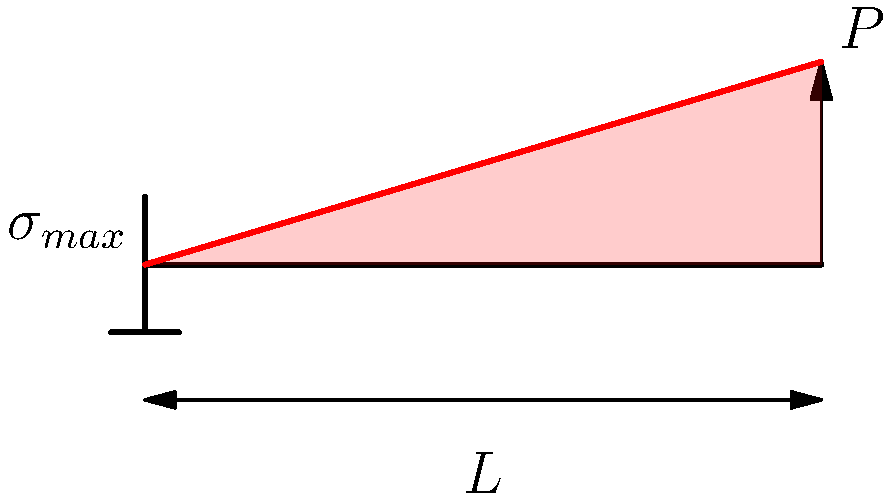In the context of international music competitions, stage design often involves cantilever structures for lighting and sound equipment. Consider a cantilever beam with length $L$ and a point load $P$ at its free end, similar to a lighting rig. If the beam has a rectangular cross-section with width $b$ and height $h$, what is the maximum stress $\sigma_{max}$ experienced at the fixed end of the beam? To find the maximum stress in a cantilever beam with a point load at the free end, we'll follow these steps:

1) The maximum bending moment $M_{max}$ occurs at the fixed end of the cantilever:
   $M_{max} = PL$

2) For a rectangular cross-section, the moment of inertia $I$ is:
   $I = \frac{1}{12}bh^3$

3) The distance from the neutral axis to the extreme fiber $c$ is:
   $c = \frac{h}{2}$

4) The general formula for bending stress is:
   $\sigma = \frac{Mc}{I}$

5) Substituting the values for $M_{max}$, $c$, and $I$:
   $\sigma_{max} = \frac{PL \cdot \frac{h}{2}}{\frac{1}{12}bh^3}$

6) Simplifying:
   $\sigma_{max} = \frac{6PL}{bh^2}$

This formula gives the maximum stress at the fixed end of the cantilever beam, which is crucial for ensuring the safety and stability of stage structures in music competitions.
Answer: $\sigma_{max} = \frac{6PL}{bh^2}$ 